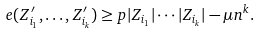<formula> <loc_0><loc_0><loc_500><loc_500>e ( Z ^ { \prime } _ { i _ { 1 } } , \dots , Z ^ { \prime } _ { i _ { k } } ) \geq p | Z _ { i _ { 1 } } | \cdots | Z _ { i _ { k } } | - \mu n ^ { k } .</formula> 